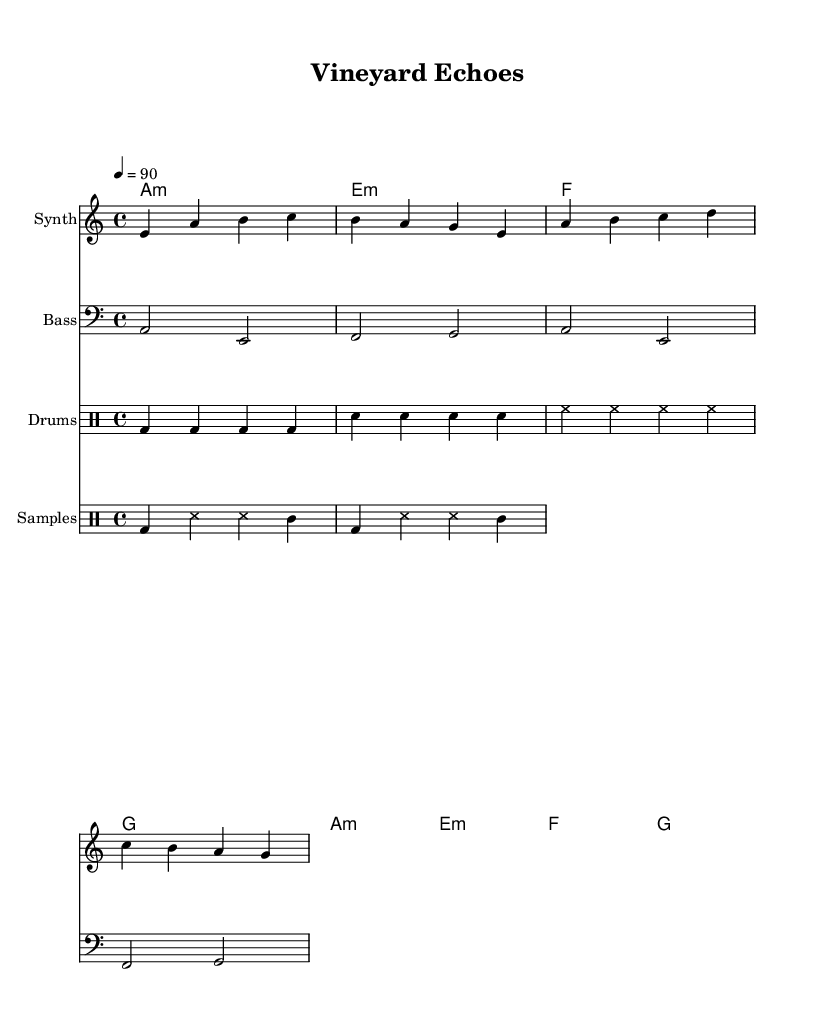What is the key signature of this music? The key signature for this piece is A minor, which contains no sharps or flats. This is determined by looking at the key signature indicated at the beginning of the score.
Answer: A minor What is the time signature of this music? The time signature displayed in the music sheet is 4/4, allowing for four beats in a measure. This can be identified by examining the notation at the beginning of the score.
Answer: 4/4 What is the tempo marking for this piece? The tempo marking reads "4 = 90," which indicates that there are 90 beats per minute. This information is found in the tempo indication also located at the start of the score.
Answer: 90 How many measures are there in the melody? The melody consists of 4 measures, as indicated by the grouping of notes across the staff lines. Each measure is separated by vertical lines, and counting these gives a total of four.
Answer: 4 What instruments are included in this composition? The composition includes a Synth, Bass, Drums, and Samples. This can be observed in the labels that precede each staff in the score, specifically identifying the different instrumental parts.
Answer: Synth, Bass, Drums, Samples What type of musical genre does this sheet music belong to? The genre for this sheet music is likely downtempo electronic, as suggested by the use of electronic instruments and the style of the composition that integrates traditional winemaking tool samples.
Answer: Downtempo electronic What sampled sounds are incorporated into the drum section? The sampled sounds included in the drum section are bass drum and tambourine. These instruments are identified in the notation under the sample label, specifying which sounds are used in the drum staff for this piece.
Answer: bass drum, tambourine 